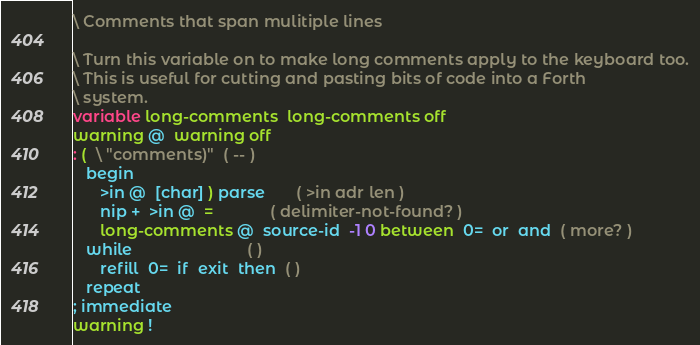Convert code to text. <code><loc_0><loc_0><loc_500><loc_500><_Forth_>\ Comments that span mulitiple lines

\ Turn this variable on to make long comments apply to the keyboard too.
\ This is useful for cutting and pasting bits of code into a Forth
\ system.
variable long-comments  long-comments off
warning @  warning off
: (  \ "comments)"  ( -- )
   begin
      >in @  [char] ) parse       ( >in adr len )
      nip +  >in @  =             ( delimiter-not-found? )
      long-comments @  source-id  -1 0 between  0=  or  and  ( more? )
   while                          ( )
      refill  0=  if  exit  then  ( )
   repeat
; immediate
warning !
</code> 